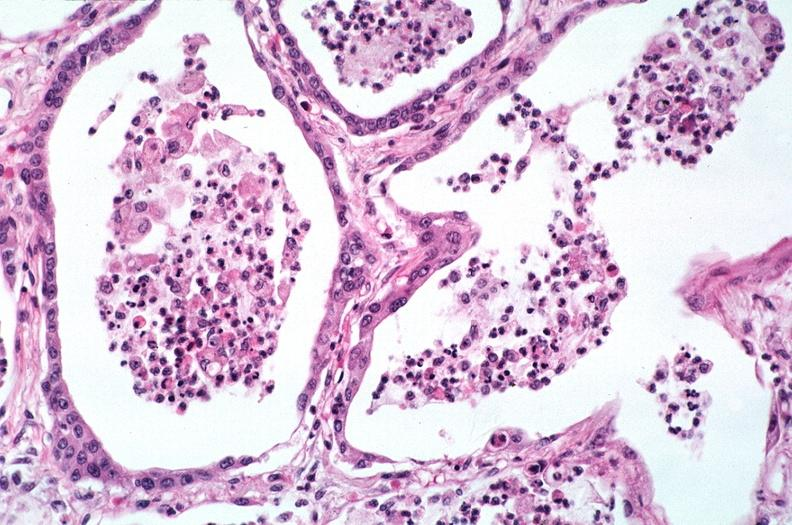does this image show lung, bronchopneumonia?
Answer the question using a single word or phrase. Yes 